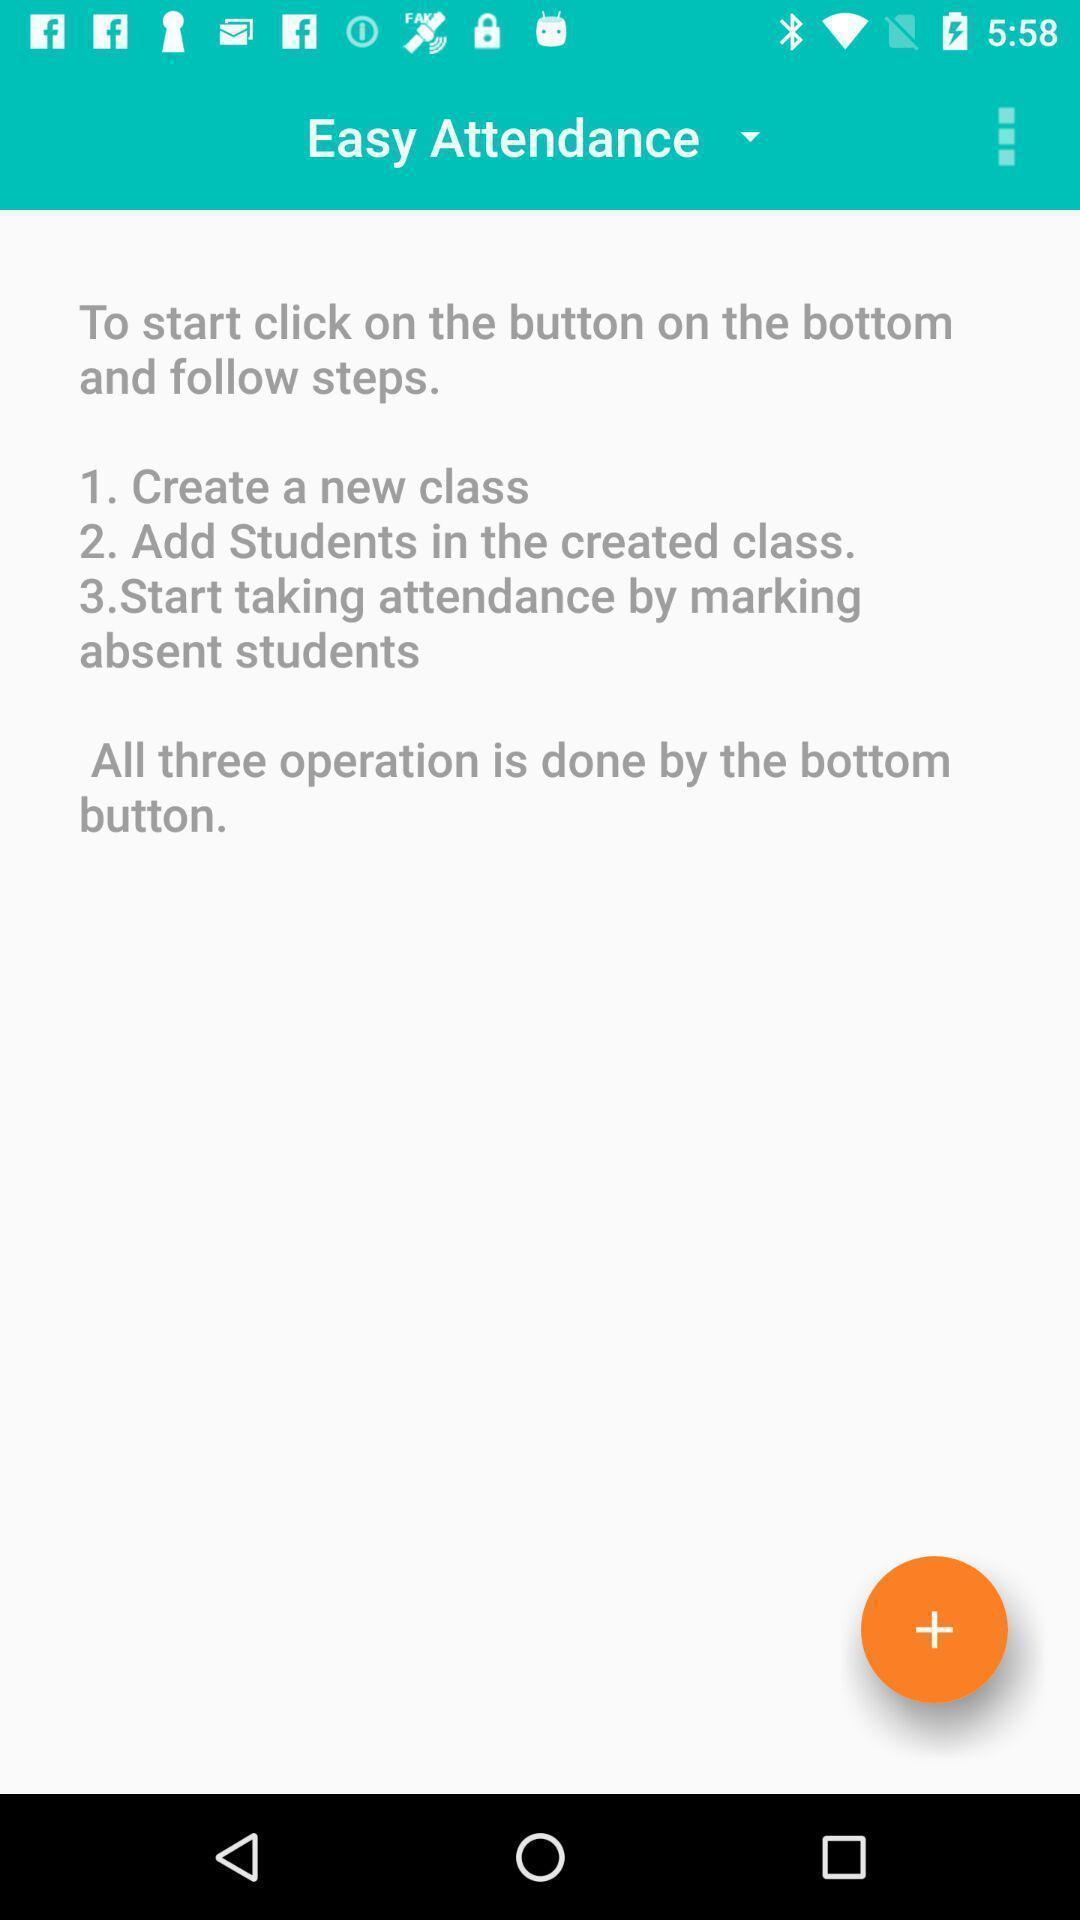Explain the elements present in this screenshot. Page with instruction for taking attendance of students. 